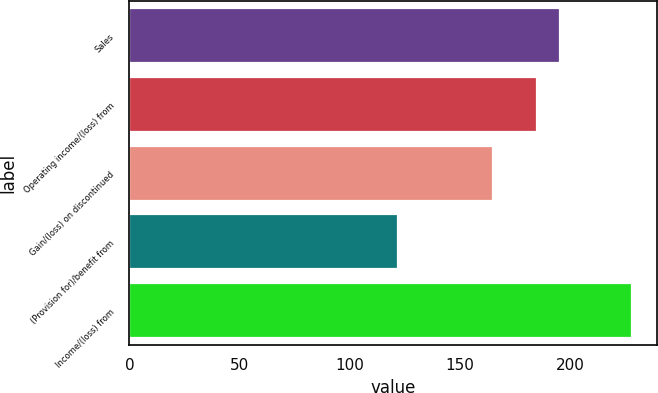<chart> <loc_0><loc_0><loc_500><loc_500><bar_chart><fcel>Sales<fcel>Operating income/(loss) from<fcel>Gain/(loss) on discontinued<fcel>(Provision for)/benefit from<fcel>Income/(loss) from<nl><fcel>195.6<fcel>185<fcel>165<fcel>122<fcel>228<nl></chart> 